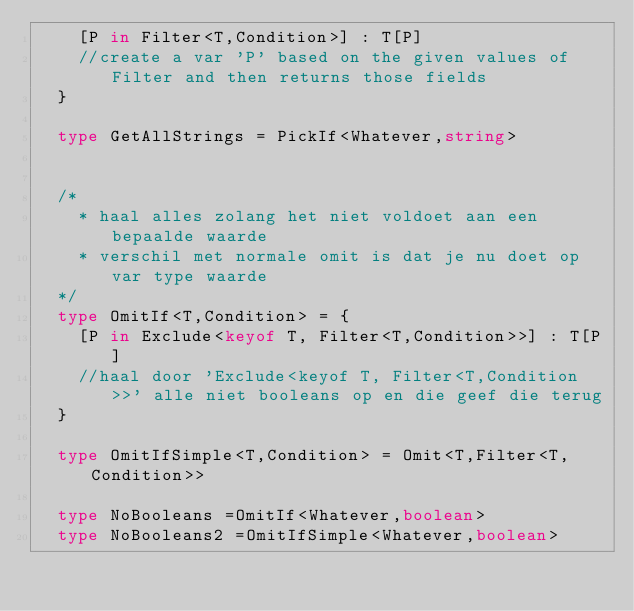<code> <loc_0><loc_0><loc_500><loc_500><_TypeScript_>    [P in Filter<T,Condition>] : T[P]
    //create a var 'P' based on the given values of Filter and then returns those fields 
  }
  
  type GetAllStrings = PickIf<Whatever,string>
  
  
  /*
    * haal alles zolang het niet voldoet aan een bepaalde waarde
    * verschil met normale omit is dat je nu doet op var type waarde
  */
  type OmitIf<T,Condition> = {
    [P in Exclude<keyof T, Filter<T,Condition>>] : T[P]
    //haal door 'Exclude<keyof T, Filter<T,Condition>>' alle niet booleans op en die geef die terug
  }
  
  type OmitIfSimple<T,Condition> = Omit<T,Filter<T,Condition>>
  
  type NoBooleans =OmitIf<Whatever,boolean>
  type NoBooleans2 =OmitIfSimple<Whatever,boolean>
  </code> 